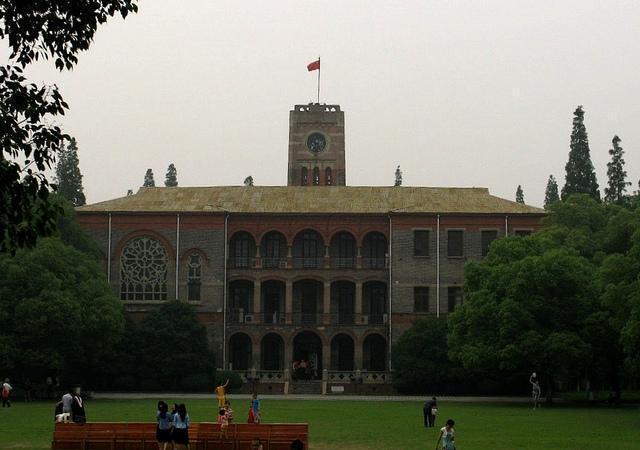What type of building is this most probably looking at the people in the courtyard?
Choose the correct response and explain in the format: 'Answer: answer
Rationale: rationale.'
Options: School, museum, housing, government office. Answer: school.
Rationale: There are several young people who might attend here. 